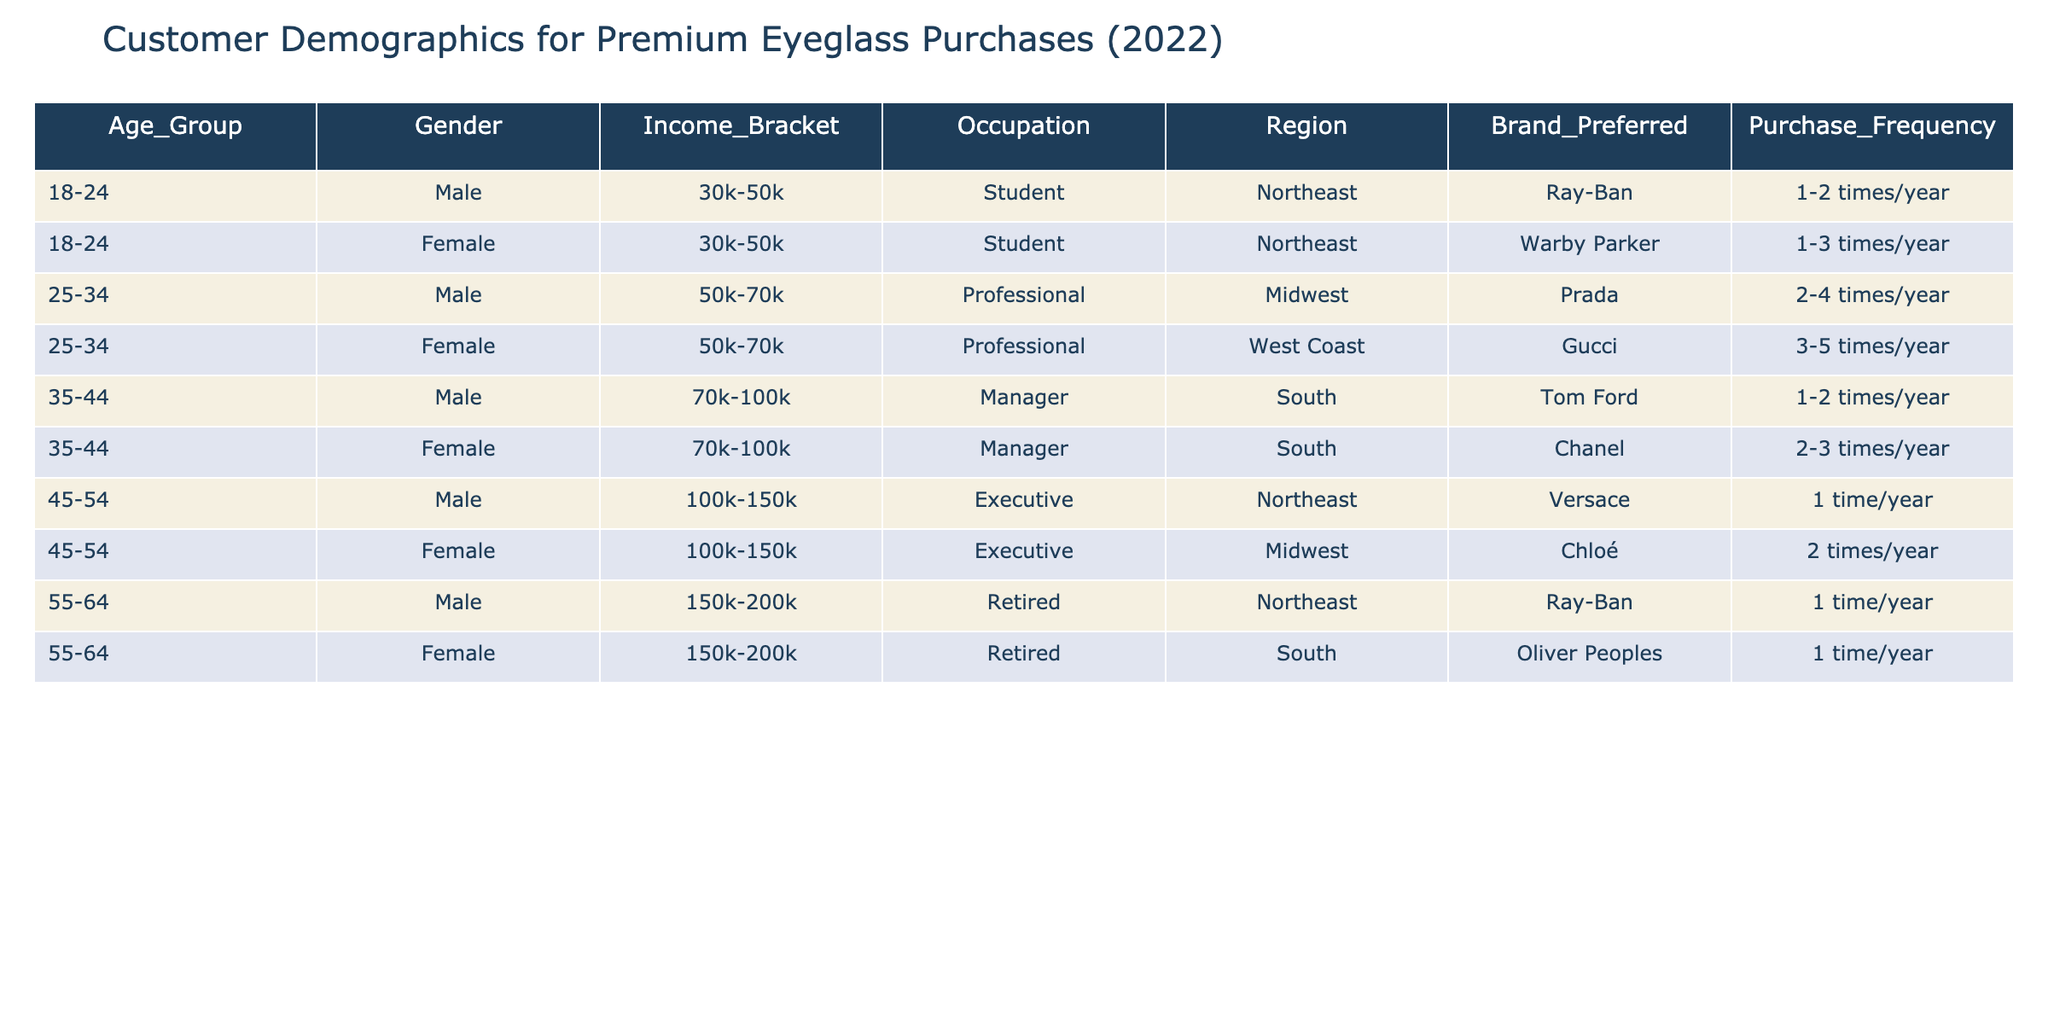What is the preferred brand of eyeglasses for the age group 45-54? In the age group 45-54, the preferred brands are Versace for males and Chloé for females, based on the entries in the table.
Answer: Versace and Chloé How many females are in the 35-44 age group? The 35-44 age group has two entries for females, one for a Manager in the South with Chanel and another for a Female from the same age group in a different region.
Answer: 2 Is there any male student in the 18-24 age group? Looking at the entries under the age group 18-24, there is one male student who prefers Ray-Ban, so the statement is true.
Answer: Yes What is the income bracket for females preferring Gucci? The female who prefers Gucci is from the 25-34 age group and has an income bracket of 50k-70k, as seen from the data.
Answer: 50k-70k What brand is preferred by the retired males in the 55-64 age group? The brand preferred by the retired males in the 55-64 age group is Ray-Ban, which can be found in the specific row for that demographic.
Answer: Ray-Ban Calculate the average purchase frequency for the 25-34 age group. There are two entries for the 25-34 age group with associated frequencies of 2-4 times/year and 3-5 times/year. To find the average, we can consider the numerical values (3, 4 for the first and 4, 5 for the second), so average frequency would be (3+4+3+4+5)/5 = 3.8 times/year.
Answer: 3.8 times/year Do all the managers in the dataset have a preference for high-end brands? There are two managers listed in the 35-44 age group, one male (Tom Ford) and one female (Chanel), both are high-end brands. So the statement is true for this dataset.
Answer: Yes Which region has the highest representation of premium eyeglass purchases for males in the 45-54 age group? The Northeast has the only Male entry for the 45-54 age group with Versace, indicating it has the highest representation for this demographic.
Answer: Northeast 